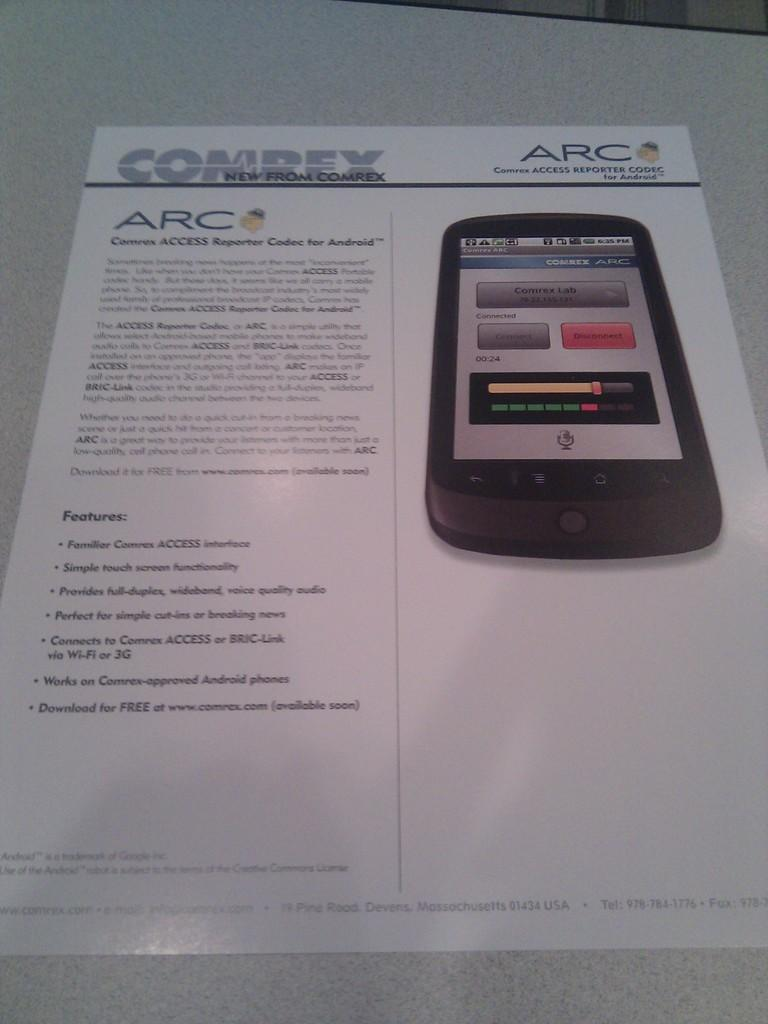<image>
Provide a brief description of the given image. Access reporter CODEC for android is a new feature from comrex. 